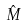<formula> <loc_0><loc_0><loc_500><loc_500>\hat { M }</formula> 